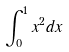<formula> <loc_0><loc_0><loc_500><loc_500>\int _ { 0 } ^ { 1 } x ^ { 2 } d x</formula> 